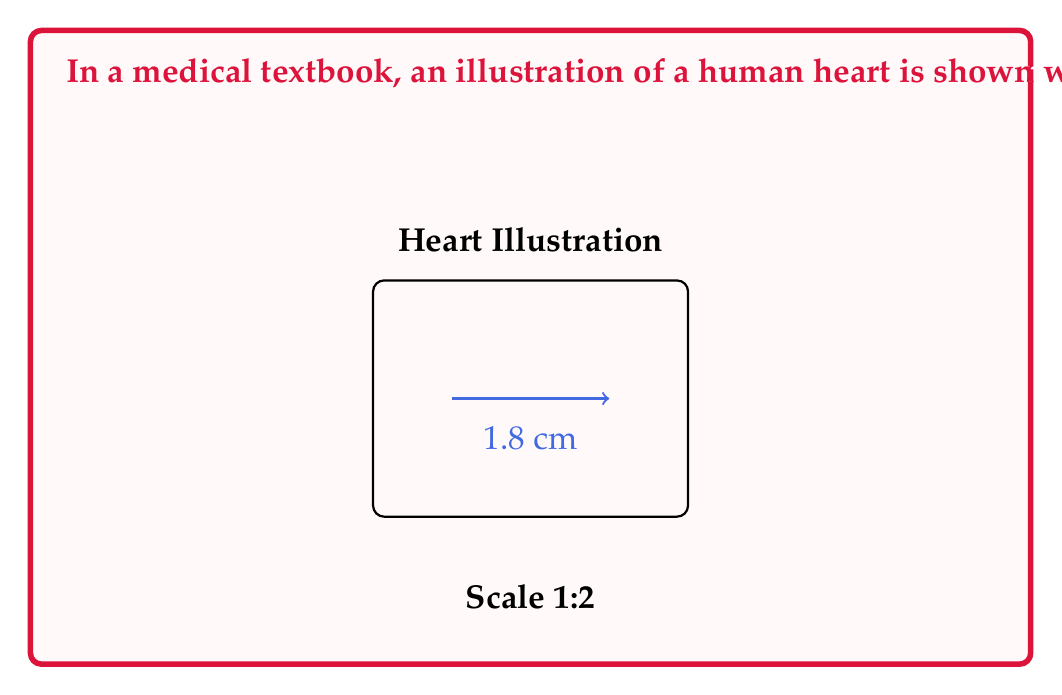Give your solution to this math problem. To solve this problem, we need to follow these steps:

1. Understand the scale:
   - The scale 1:2 means that 1 unit in the illustration represents 2 units in reality.
   - This can be expressed as a ratio: $\frac{\text{Illustration size}}{\text{Actual size}} = \frac{1}{2}$

2. Set up the proportion:
   Let $x$ be the actual length of the aorta.
   $$\frac{\text{Illustrated aorta length}}{\text{Actual aorta length}} = \frac{1}{2}$$
   $$\frac{1.8}{x} = \frac{1}{2}$$

3. Solve for $x$:
   $$1.8 \cdot 2 = x$$
   $$x = 3.6 \text{ cm}$$

4. Check the result:
   - The illustrated aorta is 1.8 cm long.
   - The actual aorta should be twice as long: $1.8 \cdot 2 = 3.6$ cm.

Therefore, the approximate actual length of the aorta in a real human heart is 3.6 cm.
Answer: 3.6 cm 